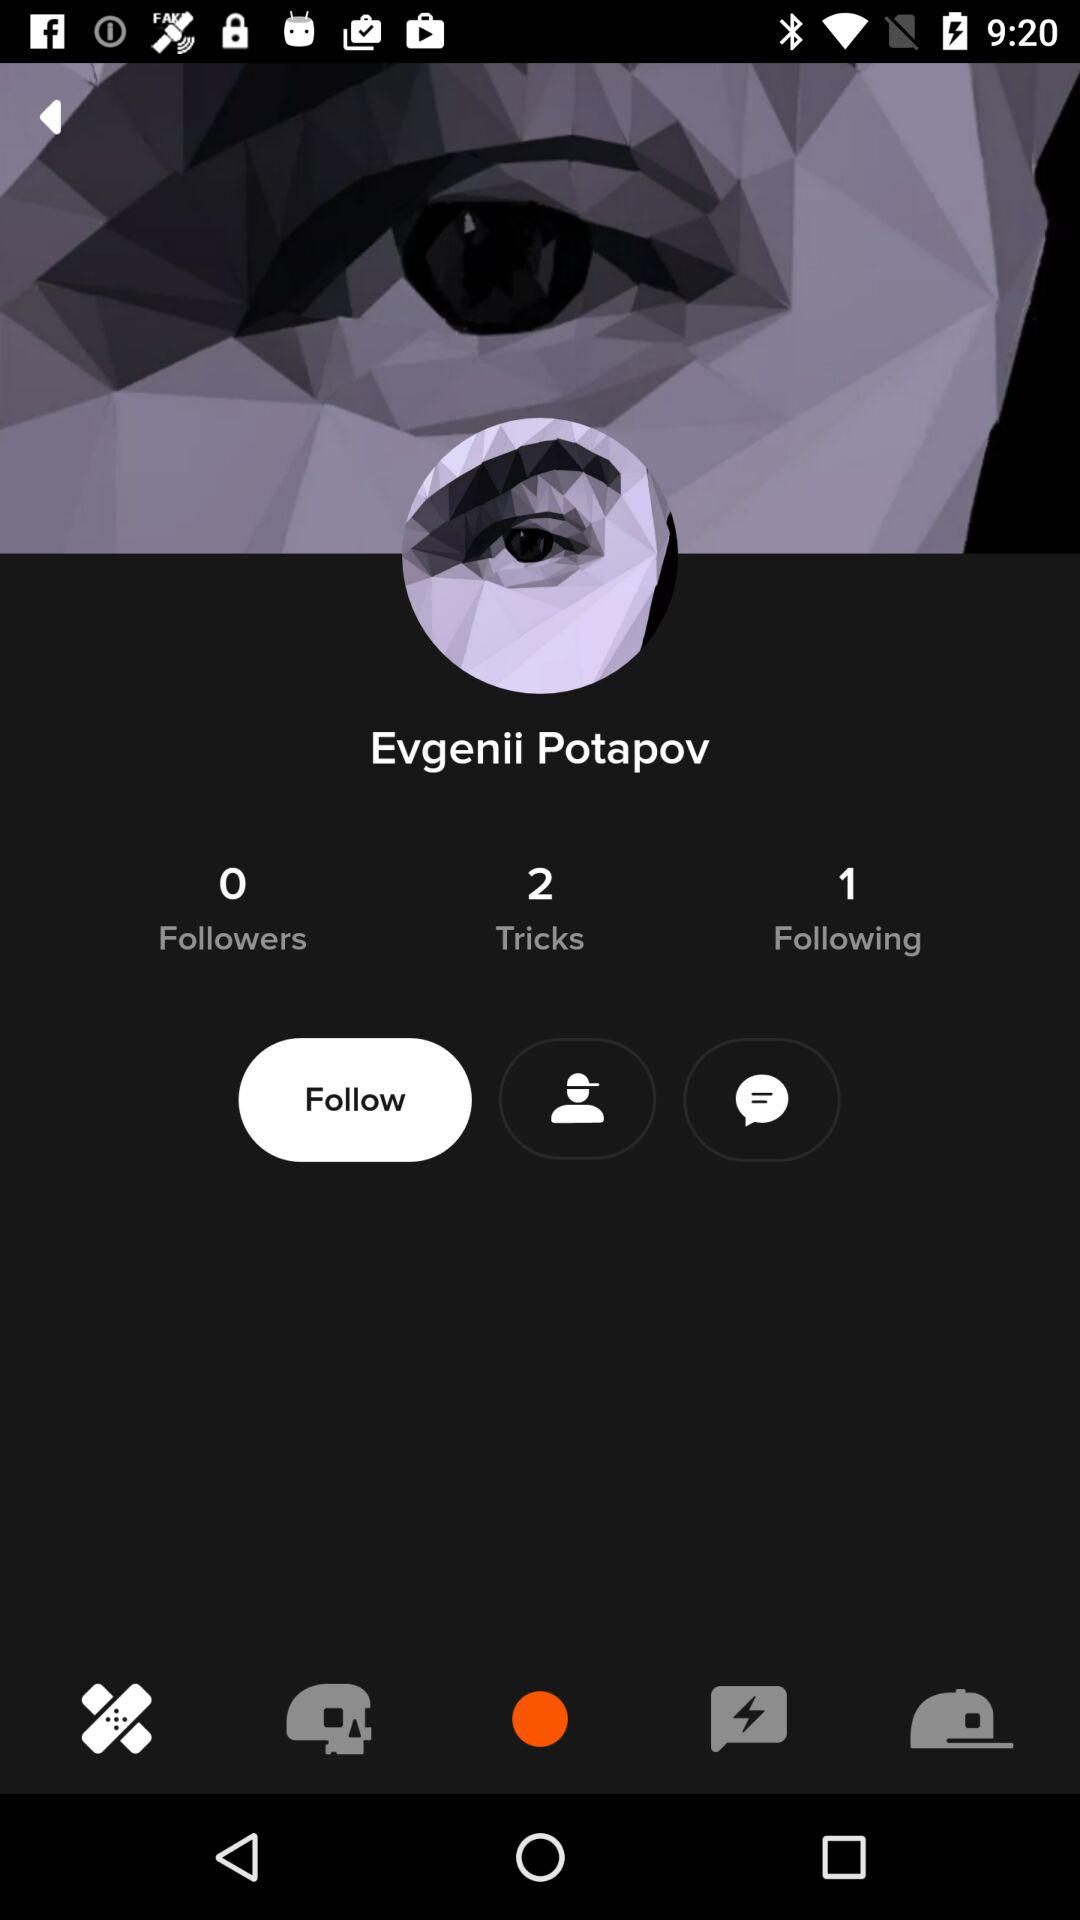How many followers of Evgenii Potapov are there? There are 0 followers. 